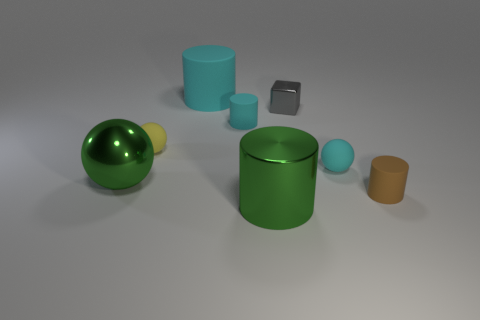Is there anything else that is made of the same material as the big green sphere?
Provide a short and direct response. Yes. There is a big metal object that is the same color as the large metal cylinder; what is its shape?
Your answer should be compact. Sphere. What is the shape of the small matte object that is right of the cyan rubber thing in front of the tiny yellow rubber sphere?
Give a very brief answer. Cylinder. Is the cube the same color as the large matte thing?
Give a very brief answer. No. The cyan ball has what size?
Give a very brief answer. Small. There is another rubber thing that is the same shape as the yellow matte object; what is its size?
Offer a very short reply. Small. What number of small cyan rubber objects are in front of the small cyan rubber object that is to the left of the tiny gray cube?
Offer a very short reply. 1. Does the big thing behind the tiny yellow matte thing have the same material as the cylinder right of the gray metal cube?
Provide a succinct answer. Yes. What number of small gray things have the same shape as the big cyan thing?
Your answer should be compact. 0. How many other cylinders are the same color as the large rubber cylinder?
Offer a very short reply. 1. 